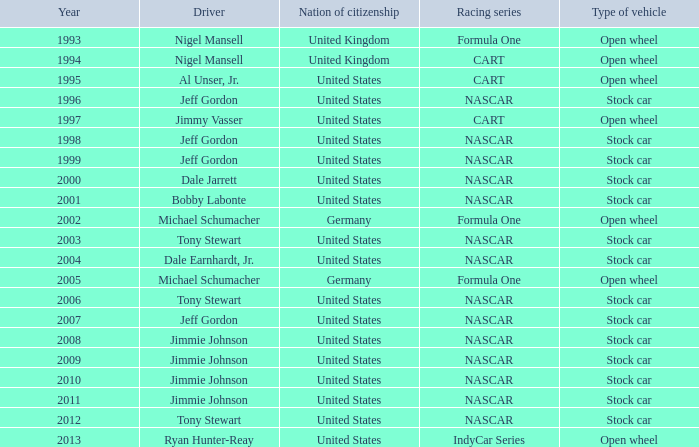What driver has a stock car vehicle with a year of 1999? Jeff Gordon. 